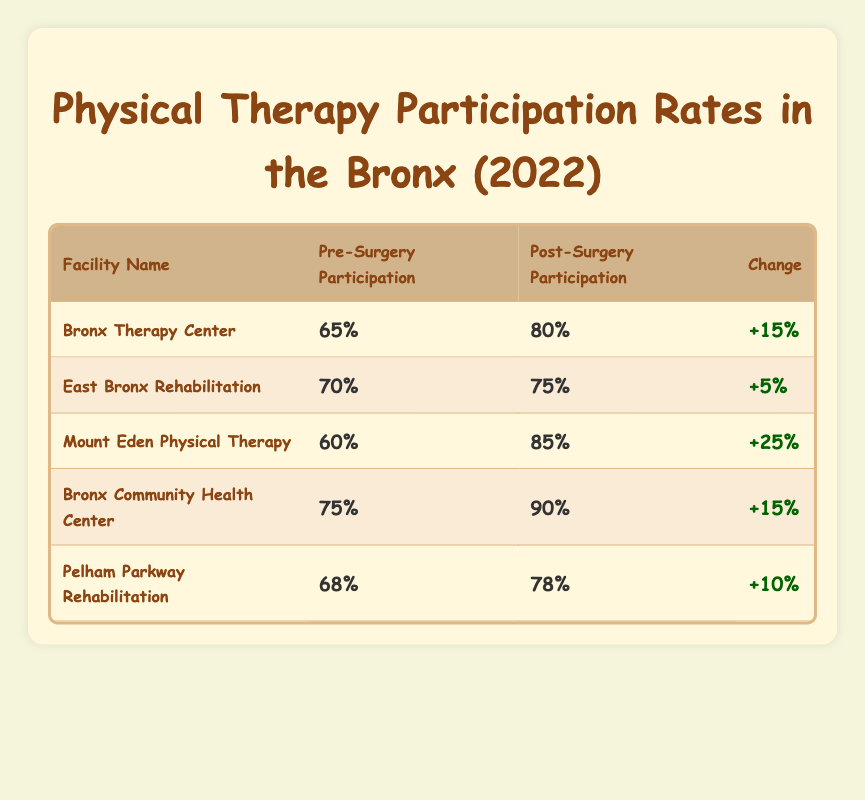What is the Pre-Surgery Participation Rate at Bronx Therapy Center? The table lists the pre-surgery participation rate for Bronx Therapy Center as 65%.
Answer: 65% Which facility had the highest Post-Surgery Participation Rate? Mount Eden Physical Therapy has the highest post-surgery participation rate at 85%.
Answer: 85% What is the change in participation rates at Bronx Community Health Center? The pre-surgery participation rate is 75% and post-surgery is 90%, so the change is 90% - 75% = 15%.
Answer: 15% Is the Post-Surgery Participation Rate at East Bronx Rehabilitation less than 80%? The post-surgery rate is 75%, which is indeed less than 80%.
Answer: Yes What is the average Pre-Surgery Participation Rate across all facilities? The pre-surgery rates are 65, 70, 60, 75, and 68. Adding these gives 338, and there are 5 facilities, so the average is 338 / 5 = 67.6%.
Answer: 67.6% Which facility had the smallest increase in participation rates? Looking at the changes: Bronx Therapy Center (+15%), East Bronx Rehabilitation (+5%), Mount Eden (+25%), Bronx Community Health Center (+15%), Pelham Parkway (+10%). East Bronx Rehabilitation had the smallest increase of +5%.
Answer: East Bronx Rehabilitation What is the difference between the highest and lowest Pre-Surgery Participation Rates? The highest rate is 75% (Bronx Community Health Center) and the lowest is 60% (Mount Eden Physical Therapy). The difference is 75% - 60% = 15%.
Answer: 15% Which two facilities had the same change in participation rates and what was that change? Bronx Therapy Center and Bronx Community Health Center both had an increase of 15% in participation rates.
Answer: 15% Is it true that Pelham Parkway Rehabilitation had a Post-Surgery Participation Rate greater than 80%? The post-surgery rate for Pelham Parkway Rehabilitation is 78%, which is not greater than 80%.
Answer: No What can you infer about the overall trend in participation rates from pre-surgery to post-surgery across all facilities? By inspecting the table, all facilities show an increase in participation rates from pre-surgery to post-surgery, indicating a positive overall trend.
Answer: Positive trend 